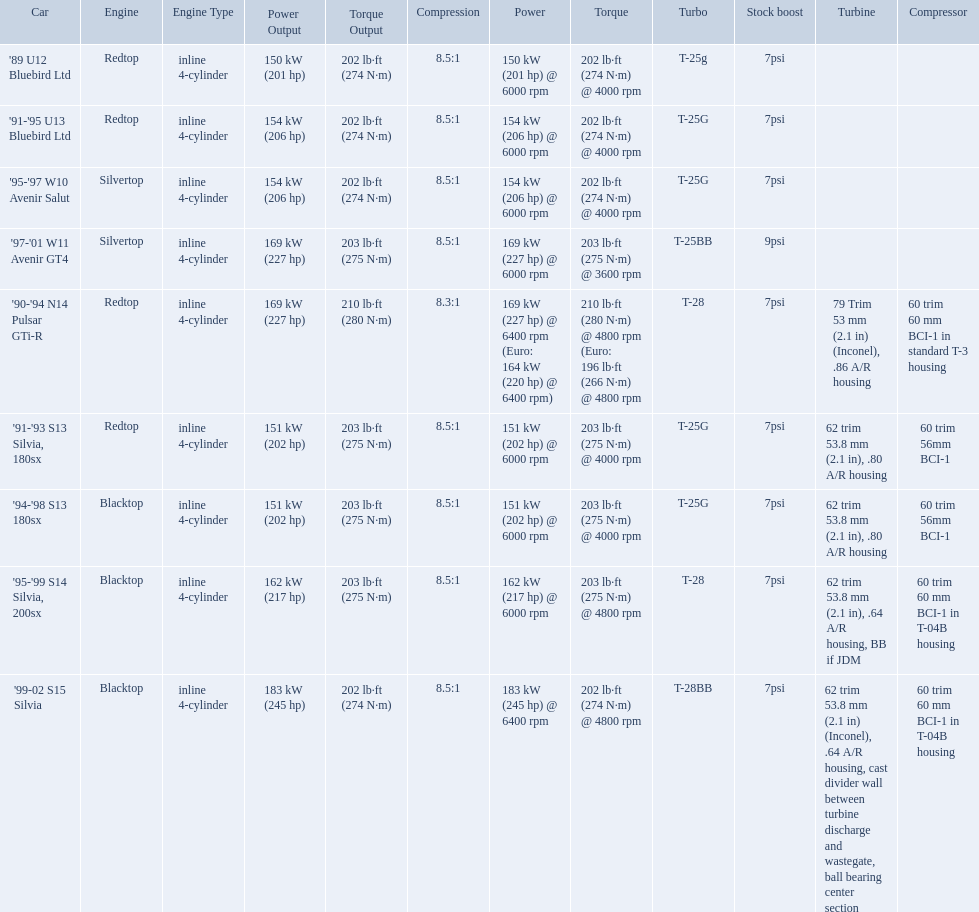Which cars featured blacktop engines? '94-'98 S13 180sx, '95-'99 S14 Silvia, 200sx, '99-02 S15 Silvia. Which of these had t-04b compressor housings? '95-'99 S14 Silvia, 200sx, '99-02 S15 Silvia. Which one of these has the highest horsepower? '99-02 S15 Silvia. What are the listed hp of the cars? 150 kW (201 hp) @ 6000 rpm, 154 kW (206 hp) @ 6000 rpm, 154 kW (206 hp) @ 6000 rpm, 169 kW (227 hp) @ 6000 rpm, 169 kW (227 hp) @ 6400 rpm (Euro: 164 kW (220 hp) @ 6400 rpm), 151 kW (202 hp) @ 6000 rpm, 151 kW (202 hp) @ 6000 rpm, 162 kW (217 hp) @ 6000 rpm, 183 kW (245 hp) @ 6400 rpm. Which is the only car with over 230 hp? '99-02 S15 Silvia. What are all of the cars? '89 U12 Bluebird Ltd, '91-'95 U13 Bluebird Ltd, '95-'97 W10 Avenir Salut, '97-'01 W11 Avenir GT4, '90-'94 N14 Pulsar GTi-R, '91-'93 S13 Silvia, 180sx, '94-'98 S13 180sx, '95-'99 S14 Silvia, 200sx, '99-02 S15 Silvia. What is their rated power? 150 kW (201 hp) @ 6000 rpm, 154 kW (206 hp) @ 6000 rpm, 154 kW (206 hp) @ 6000 rpm, 169 kW (227 hp) @ 6000 rpm, 169 kW (227 hp) @ 6400 rpm (Euro: 164 kW (220 hp) @ 6400 rpm), 151 kW (202 hp) @ 6000 rpm, 151 kW (202 hp) @ 6000 rpm, 162 kW (217 hp) @ 6000 rpm, 183 kW (245 hp) @ 6400 rpm. Which car has the most power? '99-02 S15 Silvia. What are all the cars? '89 U12 Bluebird Ltd, '91-'95 U13 Bluebird Ltd, '95-'97 W10 Avenir Salut, '97-'01 W11 Avenir GT4, '90-'94 N14 Pulsar GTi-R, '91-'93 S13 Silvia, 180sx, '94-'98 S13 180sx, '95-'99 S14 Silvia, 200sx, '99-02 S15 Silvia. What are their stock boosts? 7psi, 7psi, 7psi, 9psi, 7psi, 7psi, 7psi, 7psi, 7psi. And which car has the highest stock boost? '97-'01 W11 Avenir GT4. What cars are there? '89 U12 Bluebird Ltd, 7psi, '91-'95 U13 Bluebird Ltd, 7psi, '95-'97 W10 Avenir Salut, 7psi, '97-'01 W11 Avenir GT4, 9psi, '90-'94 N14 Pulsar GTi-R, 7psi, '91-'93 S13 Silvia, 180sx, 7psi, '94-'98 S13 180sx, 7psi, '95-'99 S14 Silvia, 200sx, 7psi, '99-02 S15 Silvia, 7psi. Which stock boost is over 7psi? '97-'01 W11 Avenir GT4, 9psi. What car is it? '97-'01 W11 Avenir GT4. Which of the cars uses the redtop engine? '89 U12 Bluebird Ltd, '91-'95 U13 Bluebird Ltd, '90-'94 N14 Pulsar GTi-R, '91-'93 S13 Silvia, 180sx. Of these, has more than 220 horsepower? '90-'94 N14 Pulsar GTi-R. What is the compression ratio of this car? 8.3:1. 